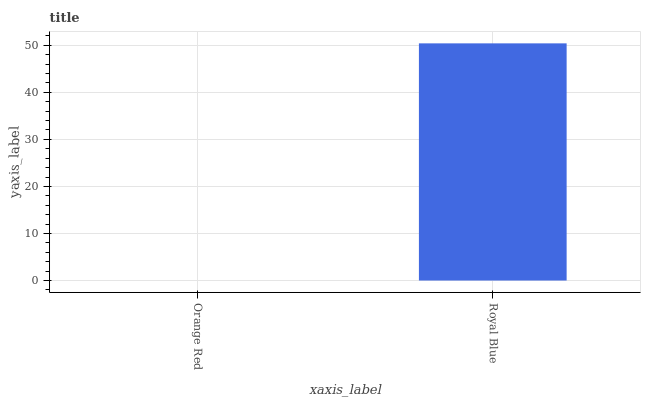Is Orange Red the minimum?
Answer yes or no. Yes. Is Royal Blue the maximum?
Answer yes or no. Yes. Is Royal Blue the minimum?
Answer yes or no. No. Is Royal Blue greater than Orange Red?
Answer yes or no. Yes. Is Orange Red less than Royal Blue?
Answer yes or no. Yes. Is Orange Red greater than Royal Blue?
Answer yes or no. No. Is Royal Blue less than Orange Red?
Answer yes or no. No. Is Royal Blue the high median?
Answer yes or no. Yes. Is Orange Red the low median?
Answer yes or no. Yes. Is Orange Red the high median?
Answer yes or no. No. Is Royal Blue the low median?
Answer yes or no. No. 